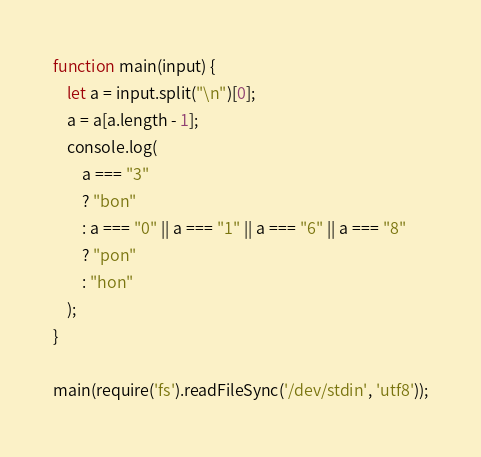Convert code to text. <code><loc_0><loc_0><loc_500><loc_500><_JavaScript_>function main(input) {
	let a = input.split("\n")[0]; 
    a = a[a.length - 1];
  	console.log(
    	a === "3"
      	? "bon"
      	: a === "0" || a === "1" || a === "6" || a === "8"
      	? "pon"
      	: "hon"
    );  
}
 
main(require('fs').readFileSync('/dev/stdin', 'utf8'));</code> 